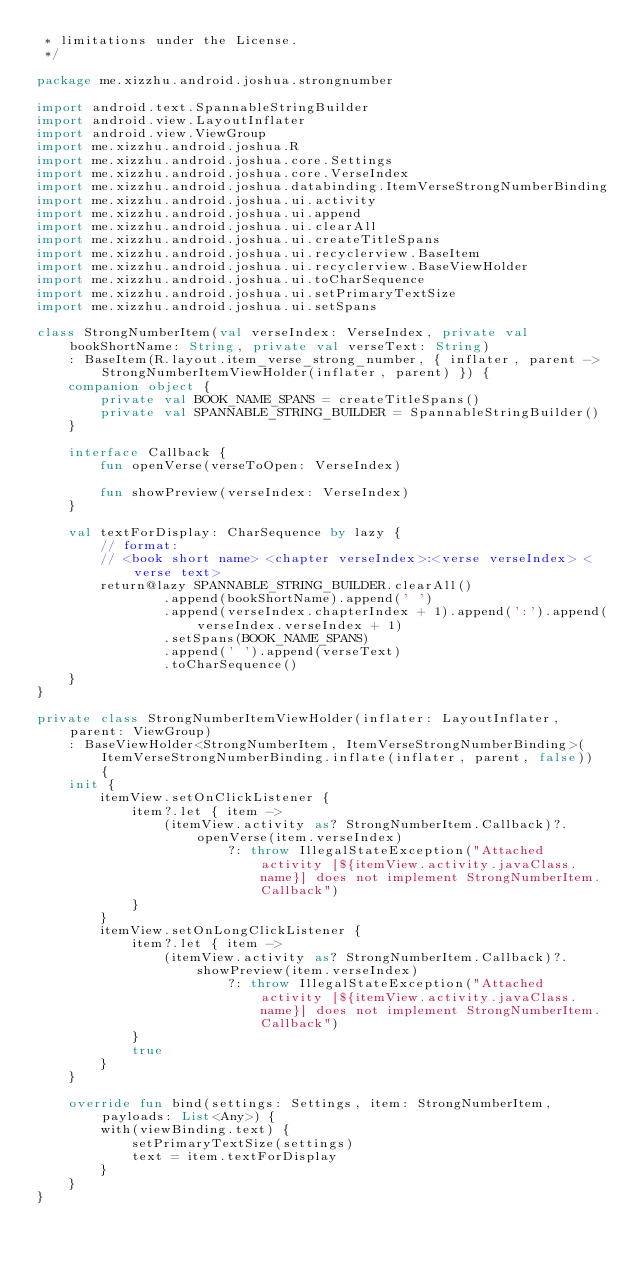<code> <loc_0><loc_0><loc_500><loc_500><_Kotlin_> * limitations under the License.
 */

package me.xizzhu.android.joshua.strongnumber

import android.text.SpannableStringBuilder
import android.view.LayoutInflater
import android.view.ViewGroup
import me.xizzhu.android.joshua.R
import me.xizzhu.android.joshua.core.Settings
import me.xizzhu.android.joshua.core.VerseIndex
import me.xizzhu.android.joshua.databinding.ItemVerseStrongNumberBinding
import me.xizzhu.android.joshua.ui.activity
import me.xizzhu.android.joshua.ui.append
import me.xizzhu.android.joshua.ui.clearAll
import me.xizzhu.android.joshua.ui.createTitleSpans
import me.xizzhu.android.joshua.ui.recyclerview.BaseItem
import me.xizzhu.android.joshua.ui.recyclerview.BaseViewHolder
import me.xizzhu.android.joshua.ui.toCharSequence
import me.xizzhu.android.joshua.ui.setPrimaryTextSize
import me.xizzhu.android.joshua.ui.setSpans

class StrongNumberItem(val verseIndex: VerseIndex, private val bookShortName: String, private val verseText: String)
    : BaseItem(R.layout.item_verse_strong_number, { inflater, parent -> StrongNumberItemViewHolder(inflater, parent) }) {
    companion object {
        private val BOOK_NAME_SPANS = createTitleSpans()
        private val SPANNABLE_STRING_BUILDER = SpannableStringBuilder()
    }

    interface Callback {
        fun openVerse(verseToOpen: VerseIndex)

        fun showPreview(verseIndex: VerseIndex)
    }

    val textForDisplay: CharSequence by lazy {
        // format:
        // <book short name> <chapter verseIndex>:<verse verseIndex> <verse text>
        return@lazy SPANNABLE_STRING_BUILDER.clearAll()
                .append(bookShortName).append(' ')
                .append(verseIndex.chapterIndex + 1).append(':').append(verseIndex.verseIndex + 1)
                .setSpans(BOOK_NAME_SPANS)
                .append(' ').append(verseText)
                .toCharSequence()
    }
}

private class StrongNumberItemViewHolder(inflater: LayoutInflater, parent: ViewGroup)
    : BaseViewHolder<StrongNumberItem, ItemVerseStrongNumberBinding>(ItemVerseStrongNumberBinding.inflate(inflater, parent, false)) {
    init {
        itemView.setOnClickListener {
            item?.let { item ->
                (itemView.activity as? StrongNumberItem.Callback)?.openVerse(item.verseIndex)
                        ?: throw IllegalStateException("Attached activity [${itemView.activity.javaClass.name}] does not implement StrongNumberItem.Callback")
            }
        }
        itemView.setOnLongClickListener {
            item?.let { item ->
                (itemView.activity as? StrongNumberItem.Callback)?.showPreview(item.verseIndex)
                        ?: throw IllegalStateException("Attached activity [${itemView.activity.javaClass.name}] does not implement StrongNumberItem.Callback")
            }
            true
        }
    }

    override fun bind(settings: Settings, item: StrongNumberItem, payloads: List<Any>) {
        with(viewBinding.text) {
            setPrimaryTextSize(settings)
            text = item.textForDisplay
        }
    }
}
</code> 